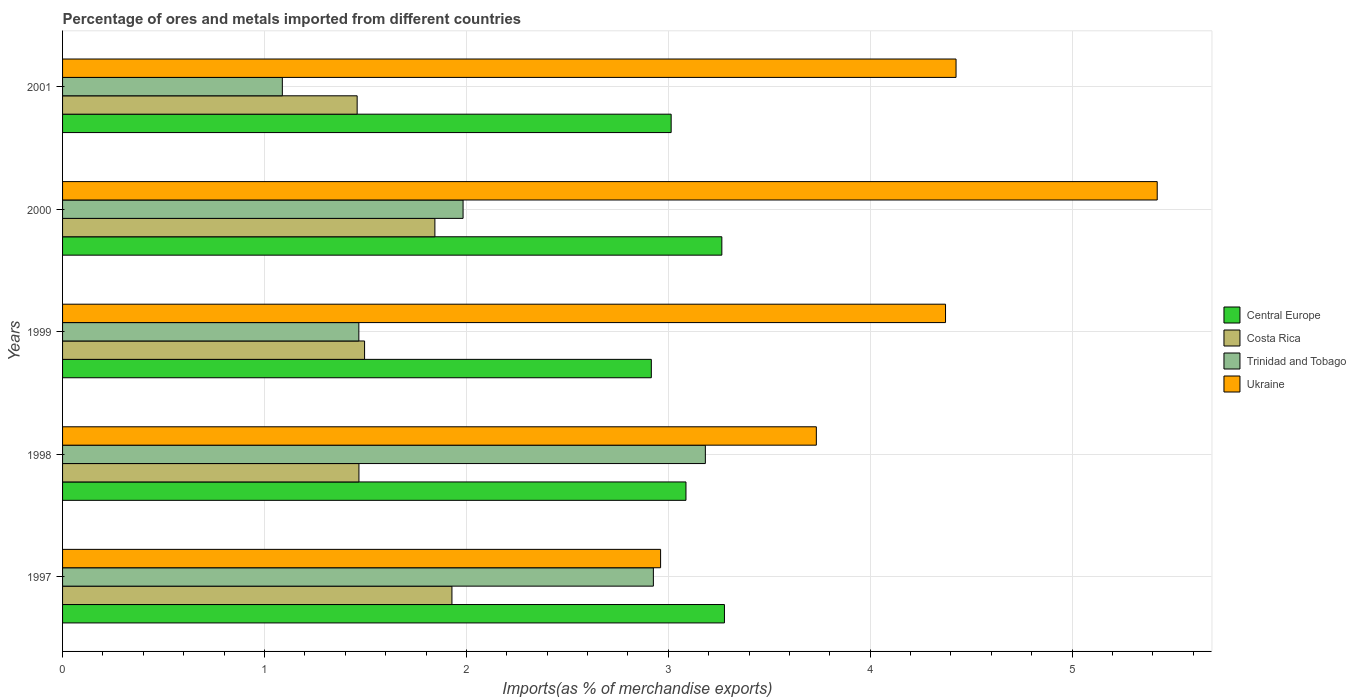How many groups of bars are there?
Make the answer very short. 5. Are the number of bars on each tick of the Y-axis equal?
Keep it short and to the point. Yes. How many bars are there on the 4th tick from the top?
Make the answer very short. 4. How many bars are there on the 2nd tick from the bottom?
Make the answer very short. 4. What is the percentage of imports to different countries in Trinidad and Tobago in 1999?
Keep it short and to the point. 1.47. Across all years, what is the maximum percentage of imports to different countries in Costa Rica?
Your answer should be compact. 1.93. Across all years, what is the minimum percentage of imports to different countries in Costa Rica?
Your response must be concise. 1.46. What is the total percentage of imports to different countries in Trinidad and Tobago in the graph?
Provide a succinct answer. 10.65. What is the difference between the percentage of imports to different countries in Central Europe in 1997 and that in 1999?
Ensure brevity in your answer.  0.36. What is the difference between the percentage of imports to different countries in Trinidad and Tobago in 2000 and the percentage of imports to different countries in Central Europe in 1997?
Offer a terse response. -1.29. What is the average percentage of imports to different countries in Costa Rica per year?
Provide a succinct answer. 1.64. In the year 1998, what is the difference between the percentage of imports to different countries in Central Europe and percentage of imports to different countries in Costa Rica?
Your answer should be very brief. 1.62. In how many years, is the percentage of imports to different countries in Costa Rica greater than 1.6 %?
Provide a succinct answer. 2. What is the ratio of the percentage of imports to different countries in Costa Rica in 1998 to that in 1999?
Provide a short and direct response. 0.98. Is the percentage of imports to different countries in Trinidad and Tobago in 1998 less than that in 2001?
Ensure brevity in your answer.  No. What is the difference between the highest and the second highest percentage of imports to different countries in Trinidad and Tobago?
Provide a short and direct response. 0.26. What is the difference between the highest and the lowest percentage of imports to different countries in Trinidad and Tobago?
Your response must be concise. 2.1. Is the sum of the percentage of imports to different countries in Costa Rica in 1998 and 1999 greater than the maximum percentage of imports to different countries in Trinidad and Tobago across all years?
Provide a succinct answer. No. Is it the case that in every year, the sum of the percentage of imports to different countries in Ukraine and percentage of imports to different countries in Costa Rica is greater than the sum of percentage of imports to different countries in Trinidad and Tobago and percentage of imports to different countries in Central Europe?
Offer a very short reply. Yes. What does the 4th bar from the top in 1998 represents?
Offer a very short reply. Central Europe. What does the 3rd bar from the bottom in 2001 represents?
Keep it short and to the point. Trinidad and Tobago. Are all the bars in the graph horizontal?
Provide a short and direct response. Yes. How many years are there in the graph?
Your answer should be very brief. 5. Are the values on the major ticks of X-axis written in scientific E-notation?
Provide a succinct answer. No. Does the graph contain any zero values?
Make the answer very short. No. What is the title of the graph?
Provide a short and direct response. Percentage of ores and metals imported from different countries. Does "Sao Tome and Principe" appear as one of the legend labels in the graph?
Keep it short and to the point. No. What is the label or title of the X-axis?
Provide a succinct answer. Imports(as % of merchandise exports). What is the label or title of the Y-axis?
Keep it short and to the point. Years. What is the Imports(as % of merchandise exports) of Central Europe in 1997?
Your answer should be compact. 3.28. What is the Imports(as % of merchandise exports) of Costa Rica in 1997?
Your answer should be very brief. 1.93. What is the Imports(as % of merchandise exports) of Trinidad and Tobago in 1997?
Offer a terse response. 2.93. What is the Imports(as % of merchandise exports) of Ukraine in 1997?
Provide a succinct answer. 2.96. What is the Imports(as % of merchandise exports) in Central Europe in 1998?
Offer a terse response. 3.09. What is the Imports(as % of merchandise exports) of Costa Rica in 1998?
Offer a terse response. 1.47. What is the Imports(as % of merchandise exports) in Trinidad and Tobago in 1998?
Ensure brevity in your answer.  3.18. What is the Imports(as % of merchandise exports) of Ukraine in 1998?
Make the answer very short. 3.73. What is the Imports(as % of merchandise exports) of Central Europe in 1999?
Your answer should be compact. 2.92. What is the Imports(as % of merchandise exports) of Costa Rica in 1999?
Offer a very short reply. 1.5. What is the Imports(as % of merchandise exports) in Trinidad and Tobago in 1999?
Your response must be concise. 1.47. What is the Imports(as % of merchandise exports) in Ukraine in 1999?
Your answer should be very brief. 4.37. What is the Imports(as % of merchandise exports) in Central Europe in 2000?
Your answer should be very brief. 3.27. What is the Imports(as % of merchandise exports) in Costa Rica in 2000?
Provide a succinct answer. 1.84. What is the Imports(as % of merchandise exports) in Trinidad and Tobago in 2000?
Give a very brief answer. 1.98. What is the Imports(as % of merchandise exports) in Ukraine in 2000?
Your answer should be very brief. 5.42. What is the Imports(as % of merchandise exports) of Central Europe in 2001?
Your response must be concise. 3.01. What is the Imports(as % of merchandise exports) in Costa Rica in 2001?
Offer a very short reply. 1.46. What is the Imports(as % of merchandise exports) in Trinidad and Tobago in 2001?
Ensure brevity in your answer.  1.09. What is the Imports(as % of merchandise exports) in Ukraine in 2001?
Provide a succinct answer. 4.43. Across all years, what is the maximum Imports(as % of merchandise exports) in Central Europe?
Your answer should be very brief. 3.28. Across all years, what is the maximum Imports(as % of merchandise exports) of Costa Rica?
Your response must be concise. 1.93. Across all years, what is the maximum Imports(as % of merchandise exports) in Trinidad and Tobago?
Provide a succinct answer. 3.18. Across all years, what is the maximum Imports(as % of merchandise exports) in Ukraine?
Your response must be concise. 5.42. Across all years, what is the minimum Imports(as % of merchandise exports) of Central Europe?
Ensure brevity in your answer.  2.92. Across all years, what is the minimum Imports(as % of merchandise exports) in Costa Rica?
Your response must be concise. 1.46. Across all years, what is the minimum Imports(as % of merchandise exports) of Trinidad and Tobago?
Ensure brevity in your answer.  1.09. Across all years, what is the minimum Imports(as % of merchandise exports) in Ukraine?
Provide a succinct answer. 2.96. What is the total Imports(as % of merchandise exports) of Central Europe in the graph?
Offer a very short reply. 15.56. What is the total Imports(as % of merchandise exports) of Costa Rica in the graph?
Provide a short and direct response. 8.2. What is the total Imports(as % of merchandise exports) in Trinidad and Tobago in the graph?
Offer a terse response. 10.65. What is the total Imports(as % of merchandise exports) in Ukraine in the graph?
Keep it short and to the point. 20.91. What is the difference between the Imports(as % of merchandise exports) in Central Europe in 1997 and that in 1998?
Give a very brief answer. 0.19. What is the difference between the Imports(as % of merchandise exports) in Costa Rica in 1997 and that in 1998?
Make the answer very short. 0.46. What is the difference between the Imports(as % of merchandise exports) in Trinidad and Tobago in 1997 and that in 1998?
Your answer should be very brief. -0.26. What is the difference between the Imports(as % of merchandise exports) of Ukraine in 1997 and that in 1998?
Offer a terse response. -0.77. What is the difference between the Imports(as % of merchandise exports) in Central Europe in 1997 and that in 1999?
Offer a very short reply. 0.36. What is the difference between the Imports(as % of merchandise exports) of Costa Rica in 1997 and that in 1999?
Offer a terse response. 0.43. What is the difference between the Imports(as % of merchandise exports) in Trinidad and Tobago in 1997 and that in 1999?
Ensure brevity in your answer.  1.46. What is the difference between the Imports(as % of merchandise exports) of Ukraine in 1997 and that in 1999?
Your response must be concise. -1.41. What is the difference between the Imports(as % of merchandise exports) of Central Europe in 1997 and that in 2000?
Your response must be concise. 0.01. What is the difference between the Imports(as % of merchandise exports) in Costa Rica in 1997 and that in 2000?
Your answer should be compact. 0.08. What is the difference between the Imports(as % of merchandise exports) of Trinidad and Tobago in 1997 and that in 2000?
Offer a very short reply. 0.94. What is the difference between the Imports(as % of merchandise exports) of Ukraine in 1997 and that in 2000?
Offer a very short reply. -2.46. What is the difference between the Imports(as % of merchandise exports) in Central Europe in 1997 and that in 2001?
Give a very brief answer. 0.26. What is the difference between the Imports(as % of merchandise exports) of Costa Rica in 1997 and that in 2001?
Provide a succinct answer. 0.47. What is the difference between the Imports(as % of merchandise exports) of Trinidad and Tobago in 1997 and that in 2001?
Offer a terse response. 1.84. What is the difference between the Imports(as % of merchandise exports) in Ukraine in 1997 and that in 2001?
Offer a very short reply. -1.46. What is the difference between the Imports(as % of merchandise exports) of Central Europe in 1998 and that in 1999?
Ensure brevity in your answer.  0.17. What is the difference between the Imports(as % of merchandise exports) of Costa Rica in 1998 and that in 1999?
Provide a succinct answer. -0.03. What is the difference between the Imports(as % of merchandise exports) in Trinidad and Tobago in 1998 and that in 1999?
Make the answer very short. 1.72. What is the difference between the Imports(as % of merchandise exports) in Ukraine in 1998 and that in 1999?
Provide a short and direct response. -0.64. What is the difference between the Imports(as % of merchandise exports) of Central Europe in 1998 and that in 2000?
Offer a terse response. -0.18. What is the difference between the Imports(as % of merchandise exports) in Costa Rica in 1998 and that in 2000?
Your answer should be compact. -0.38. What is the difference between the Imports(as % of merchandise exports) in Trinidad and Tobago in 1998 and that in 2000?
Your response must be concise. 1.2. What is the difference between the Imports(as % of merchandise exports) of Ukraine in 1998 and that in 2000?
Give a very brief answer. -1.69. What is the difference between the Imports(as % of merchandise exports) in Central Europe in 1998 and that in 2001?
Provide a short and direct response. 0.07. What is the difference between the Imports(as % of merchandise exports) in Costa Rica in 1998 and that in 2001?
Provide a short and direct response. 0.01. What is the difference between the Imports(as % of merchandise exports) in Trinidad and Tobago in 1998 and that in 2001?
Provide a succinct answer. 2.1. What is the difference between the Imports(as % of merchandise exports) in Ukraine in 1998 and that in 2001?
Ensure brevity in your answer.  -0.69. What is the difference between the Imports(as % of merchandise exports) of Central Europe in 1999 and that in 2000?
Your answer should be very brief. -0.35. What is the difference between the Imports(as % of merchandise exports) of Costa Rica in 1999 and that in 2000?
Offer a terse response. -0.35. What is the difference between the Imports(as % of merchandise exports) of Trinidad and Tobago in 1999 and that in 2000?
Provide a short and direct response. -0.52. What is the difference between the Imports(as % of merchandise exports) in Ukraine in 1999 and that in 2000?
Offer a terse response. -1.05. What is the difference between the Imports(as % of merchandise exports) of Central Europe in 1999 and that in 2001?
Your answer should be very brief. -0.1. What is the difference between the Imports(as % of merchandise exports) of Costa Rica in 1999 and that in 2001?
Keep it short and to the point. 0.04. What is the difference between the Imports(as % of merchandise exports) in Trinidad and Tobago in 1999 and that in 2001?
Provide a succinct answer. 0.38. What is the difference between the Imports(as % of merchandise exports) of Ukraine in 1999 and that in 2001?
Keep it short and to the point. -0.05. What is the difference between the Imports(as % of merchandise exports) in Central Europe in 2000 and that in 2001?
Your response must be concise. 0.25. What is the difference between the Imports(as % of merchandise exports) in Costa Rica in 2000 and that in 2001?
Offer a terse response. 0.39. What is the difference between the Imports(as % of merchandise exports) of Trinidad and Tobago in 2000 and that in 2001?
Provide a succinct answer. 0.9. What is the difference between the Imports(as % of merchandise exports) of Central Europe in 1997 and the Imports(as % of merchandise exports) of Costa Rica in 1998?
Offer a terse response. 1.81. What is the difference between the Imports(as % of merchandise exports) of Central Europe in 1997 and the Imports(as % of merchandise exports) of Trinidad and Tobago in 1998?
Give a very brief answer. 0.09. What is the difference between the Imports(as % of merchandise exports) in Central Europe in 1997 and the Imports(as % of merchandise exports) in Ukraine in 1998?
Offer a terse response. -0.46. What is the difference between the Imports(as % of merchandise exports) in Costa Rica in 1997 and the Imports(as % of merchandise exports) in Trinidad and Tobago in 1998?
Your answer should be compact. -1.26. What is the difference between the Imports(as % of merchandise exports) of Costa Rica in 1997 and the Imports(as % of merchandise exports) of Ukraine in 1998?
Provide a short and direct response. -1.8. What is the difference between the Imports(as % of merchandise exports) in Trinidad and Tobago in 1997 and the Imports(as % of merchandise exports) in Ukraine in 1998?
Your response must be concise. -0.81. What is the difference between the Imports(as % of merchandise exports) in Central Europe in 1997 and the Imports(as % of merchandise exports) in Costa Rica in 1999?
Provide a succinct answer. 1.78. What is the difference between the Imports(as % of merchandise exports) in Central Europe in 1997 and the Imports(as % of merchandise exports) in Trinidad and Tobago in 1999?
Your answer should be very brief. 1.81. What is the difference between the Imports(as % of merchandise exports) of Central Europe in 1997 and the Imports(as % of merchandise exports) of Ukraine in 1999?
Provide a succinct answer. -1.09. What is the difference between the Imports(as % of merchandise exports) of Costa Rica in 1997 and the Imports(as % of merchandise exports) of Trinidad and Tobago in 1999?
Offer a terse response. 0.46. What is the difference between the Imports(as % of merchandise exports) in Costa Rica in 1997 and the Imports(as % of merchandise exports) in Ukraine in 1999?
Offer a very short reply. -2.44. What is the difference between the Imports(as % of merchandise exports) of Trinidad and Tobago in 1997 and the Imports(as % of merchandise exports) of Ukraine in 1999?
Give a very brief answer. -1.45. What is the difference between the Imports(as % of merchandise exports) of Central Europe in 1997 and the Imports(as % of merchandise exports) of Costa Rica in 2000?
Give a very brief answer. 1.43. What is the difference between the Imports(as % of merchandise exports) in Central Europe in 1997 and the Imports(as % of merchandise exports) in Trinidad and Tobago in 2000?
Your answer should be very brief. 1.29. What is the difference between the Imports(as % of merchandise exports) in Central Europe in 1997 and the Imports(as % of merchandise exports) in Ukraine in 2000?
Offer a terse response. -2.14. What is the difference between the Imports(as % of merchandise exports) of Costa Rica in 1997 and the Imports(as % of merchandise exports) of Trinidad and Tobago in 2000?
Make the answer very short. -0.06. What is the difference between the Imports(as % of merchandise exports) of Costa Rica in 1997 and the Imports(as % of merchandise exports) of Ukraine in 2000?
Offer a terse response. -3.49. What is the difference between the Imports(as % of merchandise exports) of Trinidad and Tobago in 1997 and the Imports(as % of merchandise exports) of Ukraine in 2000?
Your answer should be very brief. -2.5. What is the difference between the Imports(as % of merchandise exports) of Central Europe in 1997 and the Imports(as % of merchandise exports) of Costa Rica in 2001?
Your answer should be very brief. 1.82. What is the difference between the Imports(as % of merchandise exports) in Central Europe in 1997 and the Imports(as % of merchandise exports) in Trinidad and Tobago in 2001?
Your answer should be compact. 2.19. What is the difference between the Imports(as % of merchandise exports) of Central Europe in 1997 and the Imports(as % of merchandise exports) of Ukraine in 2001?
Your answer should be very brief. -1.15. What is the difference between the Imports(as % of merchandise exports) of Costa Rica in 1997 and the Imports(as % of merchandise exports) of Trinidad and Tobago in 2001?
Provide a succinct answer. 0.84. What is the difference between the Imports(as % of merchandise exports) in Costa Rica in 1997 and the Imports(as % of merchandise exports) in Ukraine in 2001?
Your answer should be very brief. -2.5. What is the difference between the Imports(as % of merchandise exports) in Trinidad and Tobago in 1997 and the Imports(as % of merchandise exports) in Ukraine in 2001?
Offer a terse response. -1.5. What is the difference between the Imports(as % of merchandise exports) of Central Europe in 1998 and the Imports(as % of merchandise exports) of Costa Rica in 1999?
Ensure brevity in your answer.  1.59. What is the difference between the Imports(as % of merchandise exports) in Central Europe in 1998 and the Imports(as % of merchandise exports) in Trinidad and Tobago in 1999?
Give a very brief answer. 1.62. What is the difference between the Imports(as % of merchandise exports) in Central Europe in 1998 and the Imports(as % of merchandise exports) in Ukraine in 1999?
Keep it short and to the point. -1.29. What is the difference between the Imports(as % of merchandise exports) in Costa Rica in 1998 and the Imports(as % of merchandise exports) in Ukraine in 1999?
Make the answer very short. -2.91. What is the difference between the Imports(as % of merchandise exports) of Trinidad and Tobago in 1998 and the Imports(as % of merchandise exports) of Ukraine in 1999?
Make the answer very short. -1.19. What is the difference between the Imports(as % of merchandise exports) of Central Europe in 1998 and the Imports(as % of merchandise exports) of Costa Rica in 2000?
Provide a short and direct response. 1.24. What is the difference between the Imports(as % of merchandise exports) of Central Europe in 1998 and the Imports(as % of merchandise exports) of Trinidad and Tobago in 2000?
Provide a succinct answer. 1.1. What is the difference between the Imports(as % of merchandise exports) in Central Europe in 1998 and the Imports(as % of merchandise exports) in Ukraine in 2000?
Offer a very short reply. -2.33. What is the difference between the Imports(as % of merchandise exports) in Costa Rica in 1998 and the Imports(as % of merchandise exports) in Trinidad and Tobago in 2000?
Offer a very short reply. -0.52. What is the difference between the Imports(as % of merchandise exports) in Costa Rica in 1998 and the Imports(as % of merchandise exports) in Ukraine in 2000?
Provide a short and direct response. -3.95. What is the difference between the Imports(as % of merchandise exports) in Trinidad and Tobago in 1998 and the Imports(as % of merchandise exports) in Ukraine in 2000?
Offer a very short reply. -2.24. What is the difference between the Imports(as % of merchandise exports) in Central Europe in 1998 and the Imports(as % of merchandise exports) in Costa Rica in 2001?
Keep it short and to the point. 1.63. What is the difference between the Imports(as % of merchandise exports) in Central Europe in 1998 and the Imports(as % of merchandise exports) in Trinidad and Tobago in 2001?
Ensure brevity in your answer.  2. What is the difference between the Imports(as % of merchandise exports) of Central Europe in 1998 and the Imports(as % of merchandise exports) of Ukraine in 2001?
Offer a very short reply. -1.34. What is the difference between the Imports(as % of merchandise exports) of Costa Rica in 1998 and the Imports(as % of merchandise exports) of Trinidad and Tobago in 2001?
Your response must be concise. 0.38. What is the difference between the Imports(as % of merchandise exports) in Costa Rica in 1998 and the Imports(as % of merchandise exports) in Ukraine in 2001?
Keep it short and to the point. -2.96. What is the difference between the Imports(as % of merchandise exports) in Trinidad and Tobago in 1998 and the Imports(as % of merchandise exports) in Ukraine in 2001?
Ensure brevity in your answer.  -1.24. What is the difference between the Imports(as % of merchandise exports) in Central Europe in 1999 and the Imports(as % of merchandise exports) in Costa Rica in 2000?
Provide a short and direct response. 1.07. What is the difference between the Imports(as % of merchandise exports) in Central Europe in 1999 and the Imports(as % of merchandise exports) in Trinidad and Tobago in 2000?
Provide a short and direct response. 0.93. What is the difference between the Imports(as % of merchandise exports) of Central Europe in 1999 and the Imports(as % of merchandise exports) of Ukraine in 2000?
Your answer should be very brief. -2.51. What is the difference between the Imports(as % of merchandise exports) of Costa Rica in 1999 and the Imports(as % of merchandise exports) of Trinidad and Tobago in 2000?
Offer a terse response. -0.49. What is the difference between the Imports(as % of merchandise exports) of Costa Rica in 1999 and the Imports(as % of merchandise exports) of Ukraine in 2000?
Provide a succinct answer. -3.93. What is the difference between the Imports(as % of merchandise exports) of Trinidad and Tobago in 1999 and the Imports(as % of merchandise exports) of Ukraine in 2000?
Your answer should be very brief. -3.95. What is the difference between the Imports(as % of merchandise exports) in Central Europe in 1999 and the Imports(as % of merchandise exports) in Costa Rica in 2001?
Provide a succinct answer. 1.46. What is the difference between the Imports(as % of merchandise exports) of Central Europe in 1999 and the Imports(as % of merchandise exports) of Trinidad and Tobago in 2001?
Offer a terse response. 1.83. What is the difference between the Imports(as % of merchandise exports) in Central Europe in 1999 and the Imports(as % of merchandise exports) in Ukraine in 2001?
Provide a succinct answer. -1.51. What is the difference between the Imports(as % of merchandise exports) in Costa Rica in 1999 and the Imports(as % of merchandise exports) in Trinidad and Tobago in 2001?
Your answer should be compact. 0.41. What is the difference between the Imports(as % of merchandise exports) in Costa Rica in 1999 and the Imports(as % of merchandise exports) in Ukraine in 2001?
Ensure brevity in your answer.  -2.93. What is the difference between the Imports(as % of merchandise exports) of Trinidad and Tobago in 1999 and the Imports(as % of merchandise exports) of Ukraine in 2001?
Provide a short and direct response. -2.96. What is the difference between the Imports(as % of merchandise exports) in Central Europe in 2000 and the Imports(as % of merchandise exports) in Costa Rica in 2001?
Keep it short and to the point. 1.81. What is the difference between the Imports(as % of merchandise exports) in Central Europe in 2000 and the Imports(as % of merchandise exports) in Trinidad and Tobago in 2001?
Offer a terse response. 2.18. What is the difference between the Imports(as % of merchandise exports) of Central Europe in 2000 and the Imports(as % of merchandise exports) of Ukraine in 2001?
Offer a terse response. -1.16. What is the difference between the Imports(as % of merchandise exports) in Costa Rica in 2000 and the Imports(as % of merchandise exports) in Trinidad and Tobago in 2001?
Keep it short and to the point. 0.76. What is the difference between the Imports(as % of merchandise exports) in Costa Rica in 2000 and the Imports(as % of merchandise exports) in Ukraine in 2001?
Provide a succinct answer. -2.58. What is the difference between the Imports(as % of merchandise exports) of Trinidad and Tobago in 2000 and the Imports(as % of merchandise exports) of Ukraine in 2001?
Provide a short and direct response. -2.44. What is the average Imports(as % of merchandise exports) in Central Europe per year?
Offer a very short reply. 3.11. What is the average Imports(as % of merchandise exports) in Costa Rica per year?
Make the answer very short. 1.64. What is the average Imports(as % of merchandise exports) of Trinidad and Tobago per year?
Your answer should be very brief. 2.13. What is the average Imports(as % of merchandise exports) in Ukraine per year?
Give a very brief answer. 4.18. In the year 1997, what is the difference between the Imports(as % of merchandise exports) of Central Europe and Imports(as % of merchandise exports) of Costa Rica?
Provide a succinct answer. 1.35. In the year 1997, what is the difference between the Imports(as % of merchandise exports) in Central Europe and Imports(as % of merchandise exports) in Trinidad and Tobago?
Keep it short and to the point. 0.35. In the year 1997, what is the difference between the Imports(as % of merchandise exports) in Central Europe and Imports(as % of merchandise exports) in Ukraine?
Offer a terse response. 0.32. In the year 1997, what is the difference between the Imports(as % of merchandise exports) in Costa Rica and Imports(as % of merchandise exports) in Trinidad and Tobago?
Your answer should be compact. -1. In the year 1997, what is the difference between the Imports(as % of merchandise exports) of Costa Rica and Imports(as % of merchandise exports) of Ukraine?
Provide a succinct answer. -1.03. In the year 1997, what is the difference between the Imports(as % of merchandise exports) of Trinidad and Tobago and Imports(as % of merchandise exports) of Ukraine?
Offer a terse response. -0.04. In the year 1998, what is the difference between the Imports(as % of merchandise exports) of Central Europe and Imports(as % of merchandise exports) of Costa Rica?
Your answer should be very brief. 1.62. In the year 1998, what is the difference between the Imports(as % of merchandise exports) in Central Europe and Imports(as % of merchandise exports) in Trinidad and Tobago?
Make the answer very short. -0.1. In the year 1998, what is the difference between the Imports(as % of merchandise exports) of Central Europe and Imports(as % of merchandise exports) of Ukraine?
Your answer should be compact. -0.65. In the year 1998, what is the difference between the Imports(as % of merchandise exports) of Costa Rica and Imports(as % of merchandise exports) of Trinidad and Tobago?
Make the answer very short. -1.72. In the year 1998, what is the difference between the Imports(as % of merchandise exports) of Costa Rica and Imports(as % of merchandise exports) of Ukraine?
Offer a terse response. -2.27. In the year 1998, what is the difference between the Imports(as % of merchandise exports) of Trinidad and Tobago and Imports(as % of merchandise exports) of Ukraine?
Keep it short and to the point. -0.55. In the year 1999, what is the difference between the Imports(as % of merchandise exports) of Central Europe and Imports(as % of merchandise exports) of Costa Rica?
Make the answer very short. 1.42. In the year 1999, what is the difference between the Imports(as % of merchandise exports) in Central Europe and Imports(as % of merchandise exports) in Trinidad and Tobago?
Keep it short and to the point. 1.45. In the year 1999, what is the difference between the Imports(as % of merchandise exports) of Central Europe and Imports(as % of merchandise exports) of Ukraine?
Give a very brief answer. -1.46. In the year 1999, what is the difference between the Imports(as % of merchandise exports) in Costa Rica and Imports(as % of merchandise exports) in Trinidad and Tobago?
Offer a terse response. 0.03. In the year 1999, what is the difference between the Imports(as % of merchandise exports) of Costa Rica and Imports(as % of merchandise exports) of Ukraine?
Provide a succinct answer. -2.88. In the year 1999, what is the difference between the Imports(as % of merchandise exports) of Trinidad and Tobago and Imports(as % of merchandise exports) of Ukraine?
Your answer should be very brief. -2.91. In the year 2000, what is the difference between the Imports(as % of merchandise exports) in Central Europe and Imports(as % of merchandise exports) in Costa Rica?
Keep it short and to the point. 1.42. In the year 2000, what is the difference between the Imports(as % of merchandise exports) in Central Europe and Imports(as % of merchandise exports) in Trinidad and Tobago?
Your response must be concise. 1.28. In the year 2000, what is the difference between the Imports(as % of merchandise exports) in Central Europe and Imports(as % of merchandise exports) in Ukraine?
Your answer should be compact. -2.16. In the year 2000, what is the difference between the Imports(as % of merchandise exports) of Costa Rica and Imports(as % of merchandise exports) of Trinidad and Tobago?
Provide a succinct answer. -0.14. In the year 2000, what is the difference between the Imports(as % of merchandise exports) in Costa Rica and Imports(as % of merchandise exports) in Ukraine?
Your answer should be compact. -3.58. In the year 2000, what is the difference between the Imports(as % of merchandise exports) of Trinidad and Tobago and Imports(as % of merchandise exports) of Ukraine?
Make the answer very short. -3.44. In the year 2001, what is the difference between the Imports(as % of merchandise exports) in Central Europe and Imports(as % of merchandise exports) in Costa Rica?
Offer a very short reply. 1.56. In the year 2001, what is the difference between the Imports(as % of merchandise exports) in Central Europe and Imports(as % of merchandise exports) in Trinidad and Tobago?
Offer a terse response. 1.93. In the year 2001, what is the difference between the Imports(as % of merchandise exports) in Central Europe and Imports(as % of merchandise exports) in Ukraine?
Provide a succinct answer. -1.41. In the year 2001, what is the difference between the Imports(as % of merchandise exports) in Costa Rica and Imports(as % of merchandise exports) in Trinidad and Tobago?
Make the answer very short. 0.37. In the year 2001, what is the difference between the Imports(as % of merchandise exports) of Costa Rica and Imports(as % of merchandise exports) of Ukraine?
Ensure brevity in your answer.  -2.97. In the year 2001, what is the difference between the Imports(as % of merchandise exports) of Trinidad and Tobago and Imports(as % of merchandise exports) of Ukraine?
Your answer should be compact. -3.34. What is the ratio of the Imports(as % of merchandise exports) in Central Europe in 1997 to that in 1998?
Provide a succinct answer. 1.06. What is the ratio of the Imports(as % of merchandise exports) of Costa Rica in 1997 to that in 1998?
Your answer should be compact. 1.31. What is the ratio of the Imports(as % of merchandise exports) of Trinidad and Tobago in 1997 to that in 1998?
Your answer should be compact. 0.92. What is the ratio of the Imports(as % of merchandise exports) of Ukraine in 1997 to that in 1998?
Make the answer very short. 0.79. What is the ratio of the Imports(as % of merchandise exports) of Central Europe in 1997 to that in 1999?
Keep it short and to the point. 1.12. What is the ratio of the Imports(as % of merchandise exports) of Costa Rica in 1997 to that in 1999?
Your answer should be compact. 1.29. What is the ratio of the Imports(as % of merchandise exports) of Trinidad and Tobago in 1997 to that in 1999?
Keep it short and to the point. 1.99. What is the ratio of the Imports(as % of merchandise exports) of Ukraine in 1997 to that in 1999?
Keep it short and to the point. 0.68. What is the ratio of the Imports(as % of merchandise exports) of Central Europe in 1997 to that in 2000?
Keep it short and to the point. 1. What is the ratio of the Imports(as % of merchandise exports) in Costa Rica in 1997 to that in 2000?
Provide a succinct answer. 1.05. What is the ratio of the Imports(as % of merchandise exports) of Trinidad and Tobago in 1997 to that in 2000?
Offer a very short reply. 1.48. What is the ratio of the Imports(as % of merchandise exports) in Ukraine in 1997 to that in 2000?
Ensure brevity in your answer.  0.55. What is the ratio of the Imports(as % of merchandise exports) of Central Europe in 1997 to that in 2001?
Make the answer very short. 1.09. What is the ratio of the Imports(as % of merchandise exports) in Costa Rica in 1997 to that in 2001?
Ensure brevity in your answer.  1.32. What is the ratio of the Imports(as % of merchandise exports) in Trinidad and Tobago in 1997 to that in 2001?
Keep it short and to the point. 2.69. What is the ratio of the Imports(as % of merchandise exports) in Ukraine in 1997 to that in 2001?
Your answer should be very brief. 0.67. What is the ratio of the Imports(as % of merchandise exports) of Central Europe in 1998 to that in 1999?
Provide a succinct answer. 1.06. What is the ratio of the Imports(as % of merchandise exports) of Costa Rica in 1998 to that in 1999?
Keep it short and to the point. 0.98. What is the ratio of the Imports(as % of merchandise exports) in Trinidad and Tobago in 1998 to that in 1999?
Your answer should be compact. 2.17. What is the ratio of the Imports(as % of merchandise exports) in Ukraine in 1998 to that in 1999?
Ensure brevity in your answer.  0.85. What is the ratio of the Imports(as % of merchandise exports) of Central Europe in 1998 to that in 2000?
Provide a short and direct response. 0.95. What is the ratio of the Imports(as % of merchandise exports) of Costa Rica in 1998 to that in 2000?
Your answer should be compact. 0.8. What is the ratio of the Imports(as % of merchandise exports) of Trinidad and Tobago in 1998 to that in 2000?
Offer a terse response. 1.6. What is the ratio of the Imports(as % of merchandise exports) of Ukraine in 1998 to that in 2000?
Offer a very short reply. 0.69. What is the ratio of the Imports(as % of merchandise exports) in Central Europe in 1998 to that in 2001?
Ensure brevity in your answer.  1.02. What is the ratio of the Imports(as % of merchandise exports) of Trinidad and Tobago in 1998 to that in 2001?
Ensure brevity in your answer.  2.92. What is the ratio of the Imports(as % of merchandise exports) in Ukraine in 1998 to that in 2001?
Make the answer very short. 0.84. What is the ratio of the Imports(as % of merchandise exports) in Central Europe in 1999 to that in 2000?
Your answer should be very brief. 0.89. What is the ratio of the Imports(as % of merchandise exports) in Costa Rica in 1999 to that in 2000?
Give a very brief answer. 0.81. What is the ratio of the Imports(as % of merchandise exports) of Trinidad and Tobago in 1999 to that in 2000?
Provide a succinct answer. 0.74. What is the ratio of the Imports(as % of merchandise exports) of Ukraine in 1999 to that in 2000?
Ensure brevity in your answer.  0.81. What is the ratio of the Imports(as % of merchandise exports) in Central Europe in 1999 to that in 2001?
Provide a succinct answer. 0.97. What is the ratio of the Imports(as % of merchandise exports) of Costa Rica in 1999 to that in 2001?
Ensure brevity in your answer.  1.03. What is the ratio of the Imports(as % of merchandise exports) of Trinidad and Tobago in 1999 to that in 2001?
Offer a terse response. 1.35. What is the ratio of the Imports(as % of merchandise exports) of Costa Rica in 2000 to that in 2001?
Make the answer very short. 1.26. What is the ratio of the Imports(as % of merchandise exports) in Trinidad and Tobago in 2000 to that in 2001?
Your response must be concise. 1.82. What is the ratio of the Imports(as % of merchandise exports) in Ukraine in 2000 to that in 2001?
Your answer should be compact. 1.23. What is the difference between the highest and the second highest Imports(as % of merchandise exports) in Central Europe?
Make the answer very short. 0.01. What is the difference between the highest and the second highest Imports(as % of merchandise exports) in Costa Rica?
Provide a succinct answer. 0.08. What is the difference between the highest and the second highest Imports(as % of merchandise exports) in Trinidad and Tobago?
Provide a short and direct response. 0.26. What is the difference between the highest and the lowest Imports(as % of merchandise exports) of Central Europe?
Offer a terse response. 0.36. What is the difference between the highest and the lowest Imports(as % of merchandise exports) of Costa Rica?
Ensure brevity in your answer.  0.47. What is the difference between the highest and the lowest Imports(as % of merchandise exports) of Trinidad and Tobago?
Offer a very short reply. 2.1. What is the difference between the highest and the lowest Imports(as % of merchandise exports) in Ukraine?
Offer a terse response. 2.46. 